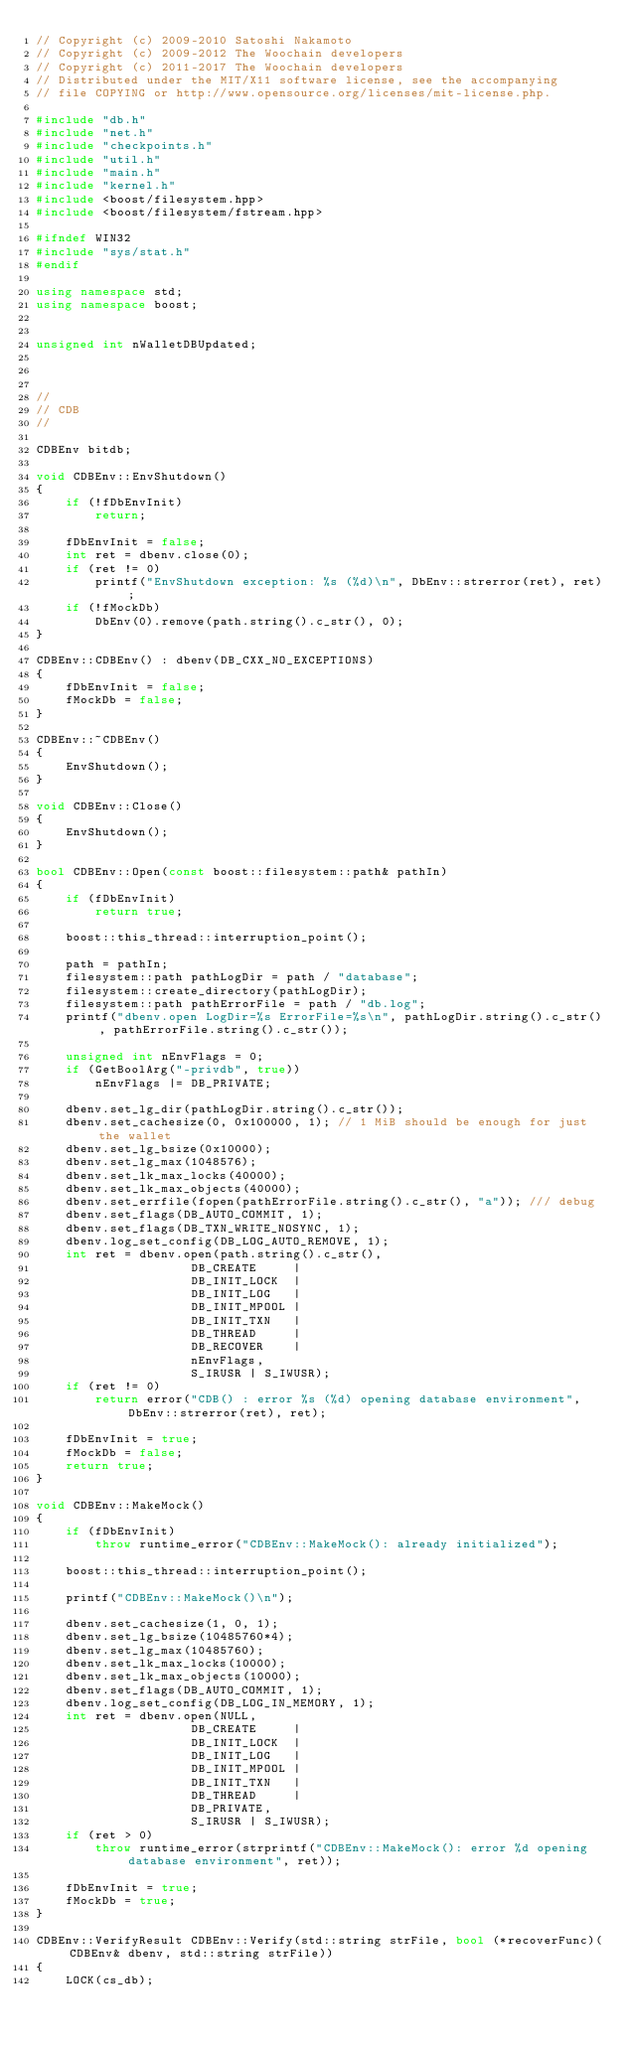Convert code to text. <code><loc_0><loc_0><loc_500><loc_500><_C++_>// Copyright (c) 2009-2010 Satoshi Nakamoto
// Copyright (c) 2009-2012 The Woochain developers
// Copyright (c) 2011-2017 The Woochain developers
// Distributed under the MIT/X11 software license, see the accompanying
// file COPYING or http://www.opensource.org/licenses/mit-license.php.

#include "db.h"
#include "net.h"
#include "checkpoints.h"
#include "util.h"
#include "main.h"
#include "kernel.h"
#include <boost/filesystem.hpp>
#include <boost/filesystem/fstream.hpp>

#ifndef WIN32
#include "sys/stat.h"
#endif

using namespace std;
using namespace boost;


unsigned int nWalletDBUpdated;



//
// CDB
//

CDBEnv bitdb;

void CDBEnv::EnvShutdown()
{
    if (!fDbEnvInit)
        return;

    fDbEnvInit = false;
    int ret = dbenv.close(0);
    if (ret != 0)
        printf("EnvShutdown exception: %s (%d)\n", DbEnv::strerror(ret), ret);
    if (!fMockDb)
        DbEnv(0).remove(path.string().c_str(), 0);
}

CDBEnv::CDBEnv() : dbenv(DB_CXX_NO_EXCEPTIONS)
{
    fDbEnvInit = false;
    fMockDb = false;
}

CDBEnv::~CDBEnv()
{
    EnvShutdown();
}

void CDBEnv::Close()
{
    EnvShutdown();
}

bool CDBEnv::Open(const boost::filesystem::path& pathIn)
{
    if (fDbEnvInit)
        return true;

    boost::this_thread::interruption_point();

    path = pathIn;
    filesystem::path pathLogDir = path / "database";
    filesystem::create_directory(pathLogDir);
    filesystem::path pathErrorFile = path / "db.log";
    printf("dbenv.open LogDir=%s ErrorFile=%s\n", pathLogDir.string().c_str(), pathErrorFile.string().c_str());

    unsigned int nEnvFlags = 0;
    if (GetBoolArg("-privdb", true))
        nEnvFlags |= DB_PRIVATE;

    dbenv.set_lg_dir(pathLogDir.string().c_str());
    dbenv.set_cachesize(0, 0x100000, 1); // 1 MiB should be enough for just the wallet
    dbenv.set_lg_bsize(0x10000);
    dbenv.set_lg_max(1048576);
    dbenv.set_lk_max_locks(40000);
    dbenv.set_lk_max_objects(40000);
    dbenv.set_errfile(fopen(pathErrorFile.string().c_str(), "a")); /// debug
    dbenv.set_flags(DB_AUTO_COMMIT, 1);
    dbenv.set_flags(DB_TXN_WRITE_NOSYNC, 1);
    dbenv.log_set_config(DB_LOG_AUTO_REMOVE, 1);
    int ret = dbenv.open(path.string().c_str(),
                     DB_CREATE     |
                     DB_INIT_LOCK  |
                     DB_INIT_LOG   |
                     DB_INIT_MPOOL |
                     DB_INIT_TXN   |
                     DB_THREAD     |
                     DB_RECOVER    |
                     nEnvFlags,
                     S_IRUSR | S_IWUSR);
    if (ret != 0)
        return error("CDB() : error %s (%d) opening database environment", DbEnv::strerror(ret), ret);

    fDbEnvInit = true;
    fMockDb = false;
    return true;
}

void CDBEnv::MakeMock()
{
    if (fDbEnvInit)
        throw runtime_error("CDBEnv::MakeMock(): already initialized");

    boost::this_thread::interruption_point();

    printf("CDBEnv::MakeMock()\n");

    dbenv.set_cachesize(1, 0, 1);
    dbenv.set_lg_bsize(10485760*4);
    dbenv.set_lg_max(10485760);
    dbenv.set_lk_max_locks(10000);
    dbenv.set_lk_max_objects(10000);
    dbenv.set_flags(DB_AUTO_COMMIT, 1);
    dbenv.log_set_config(DB_LOG_IN_MEMORY, 1);
    int ret = dbenv.open(NULL,
                     DB_CREATE     |
                     DB_INIT_LOCK  |
                     DB_INIT_LOG   |
                     DB_INIT_MPOOL |
                     DB_INIT_TXN   |
                     DB_THREAD     |
                     DB_PRIVATE,
                     S_IRUSR | S_IWUSR);
    if (ret > 0)
        throw runtime_error(strprintf("CDBEnv::MakeMock(): error %d opening database environment", ret));

    fDbEnvInit = true;
    fMockDb = true;
}

CDBEnv::VerifyResult CDBEnv::Verify(std::string strFile, bool (*recoverFunc)(CDBEnv& dbenv, std::string strFile))
{
    LOCK(cs_db);</code> 